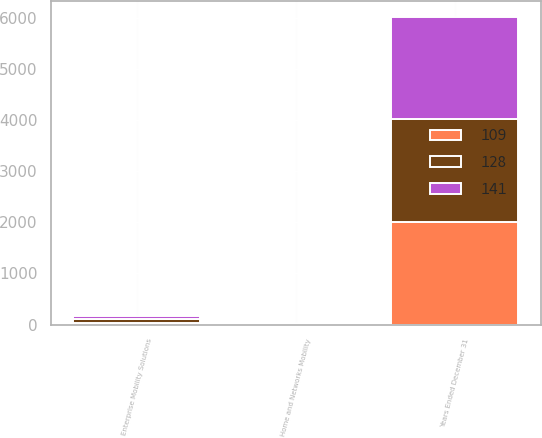Convert chart. <chart><loc_0><loc_0><loc_500><loc_500><stacked_bar_chart><ecel><fcel>Years Ended December 31<fcel>Home and Networks Mobility<fcel>Enterprise Mobility Solutions<nl><fcel>128<fcel>2008<fcel>2<fcel>86<nl><fcel>141<fcel>2007<fcel>14<fcel>58<nl><fcel>109<fcel>2006<fcel>13<fcel>31<nl></chart> 